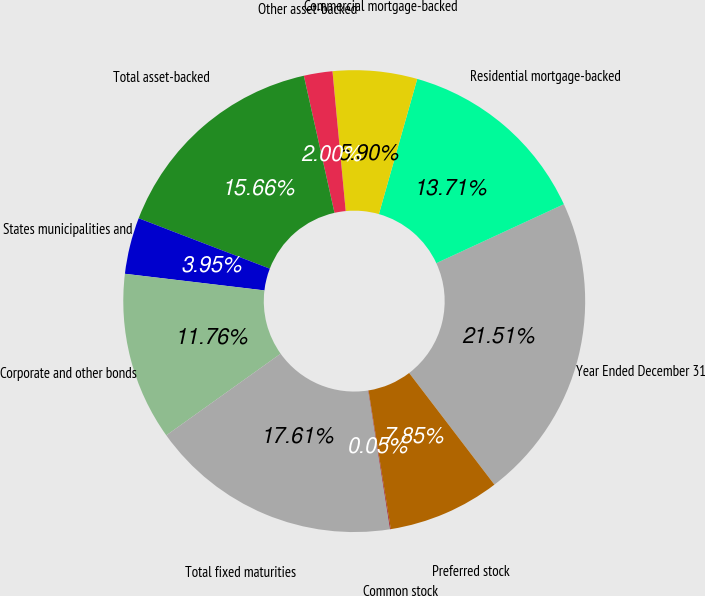Convert chart to OTSL. <chart><loc_0><loc_0><loc_500><loc_500><pie_chart><fcel>Year Ended December 31<fcel>Residential mortgage-backed<fcel>Commercial mortgage-backed<fcel>Other asset-backed<fcel>Total asset-backed<fcel>States municipalities and<fcel>Corporate and other bonds<fcel>Total fixed maturities<fcel>Common stock<fcel>Preferred stock<nl><fcel>21.51%<fcel>13.71%<fcel>5.9%<fcel>2.0%<fcel>15.66%<fcel>3.95%<fcel>11.76%<fcel>17.61%<fcel>0.05%<fcel>7.85%<nl></chart> 